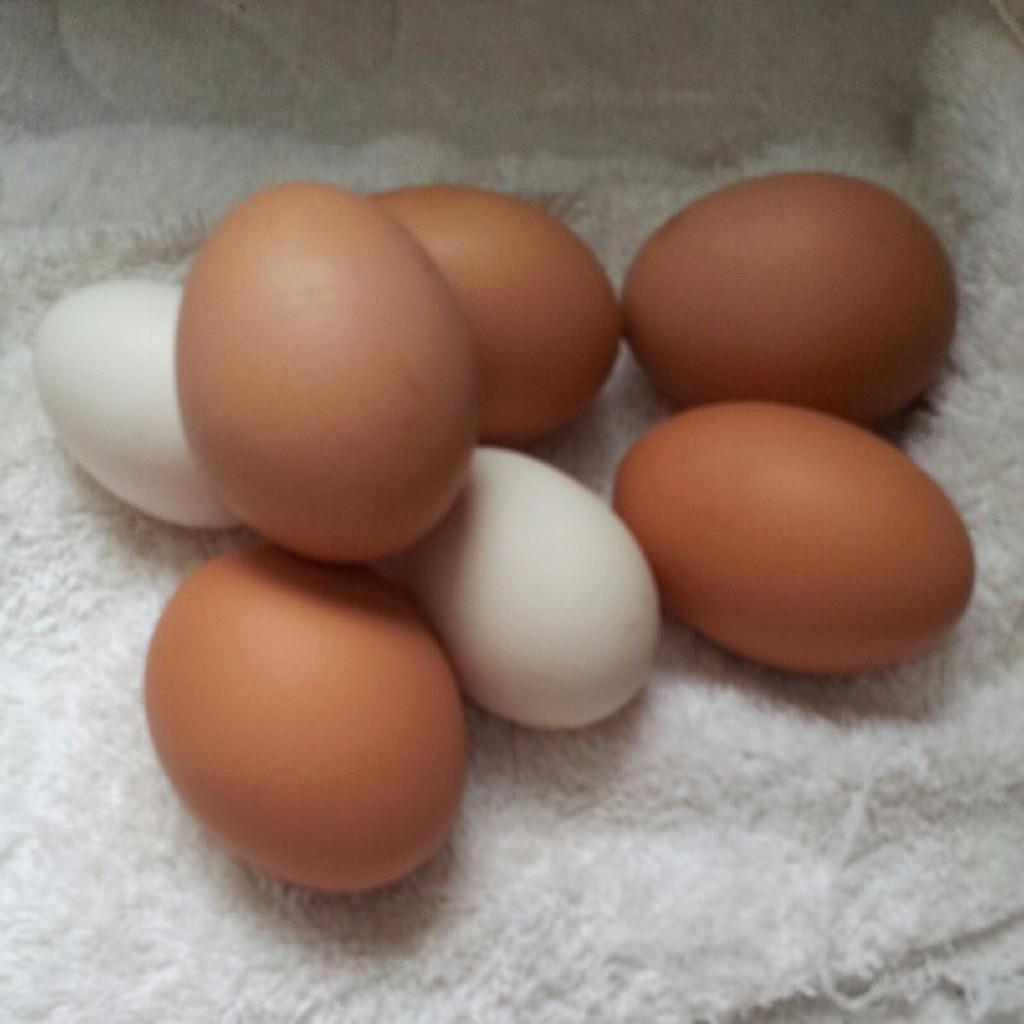What type of food items are present in the image? There are eggs in the image. Can you describe the color of the eggs? The eggs are of white and brown color. How are the eggs arranged or placed in the image? The eggs are kept on a cloth. What type of kitten can be seen playing with a brake in the image? There is no kitten or brake present in the image; it only features eggs on a cloth. Is the whip used to crack the eggs in the image? There is no whip present in the image, and eggs are not cracked in any way. 